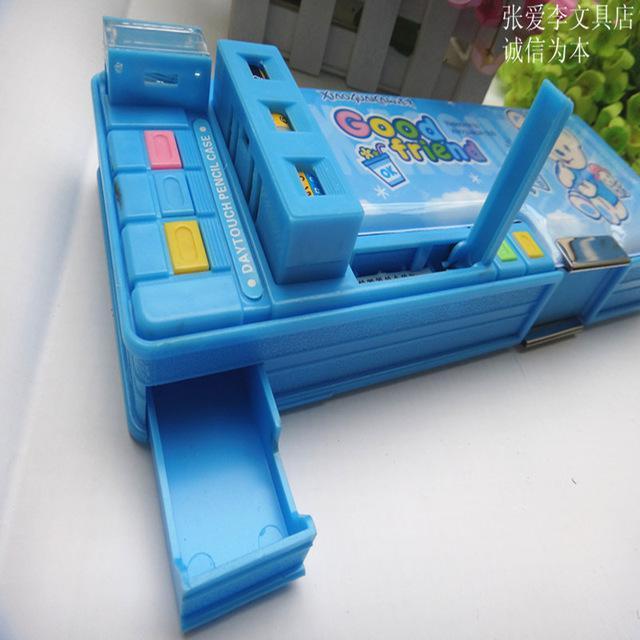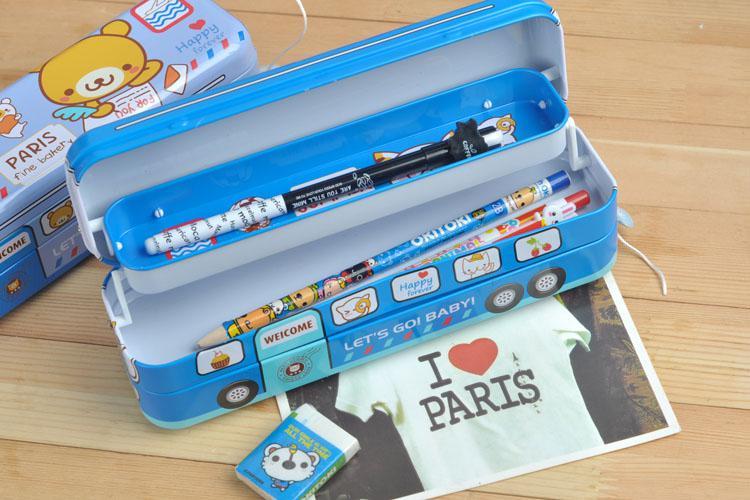The first image is the image on the left, the second image is the image on the right. Considering the images on both sides, is "Each image only contains one showcased item" valid? Answer yes or no. No. 